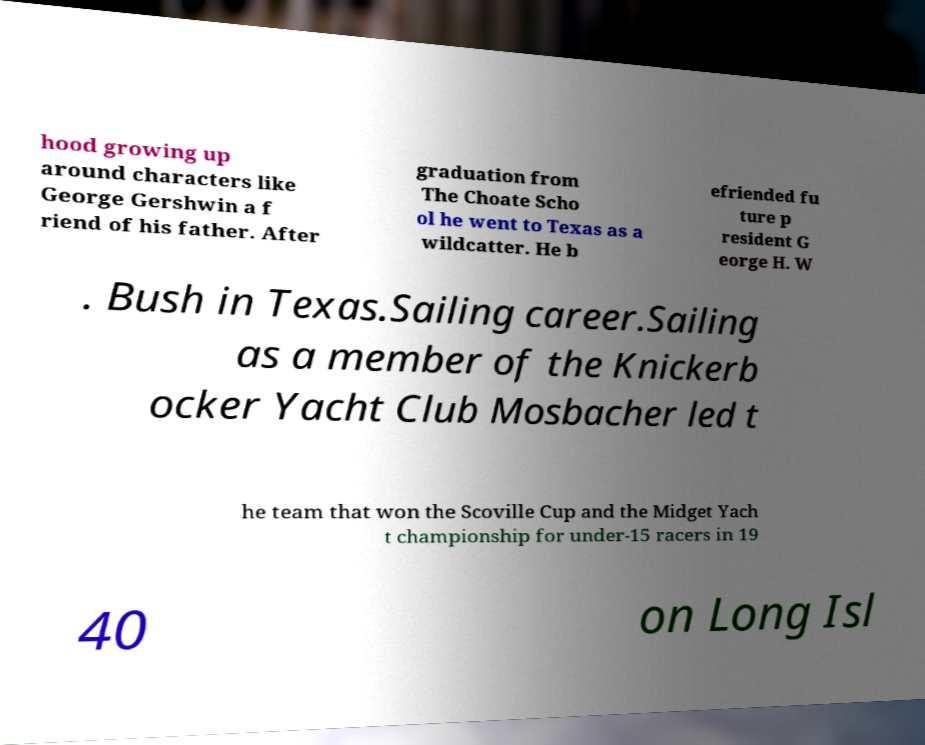Could you extract and type out the text from this image? hood growing up around characters like George Gershwin a f riend of his father. After graduation from The Choate Scho ol he went to Texas as a wildcatter. He b efriended fu ture p resident G eorge H. W . Bush in Texas.Sailing career.Sailing as a member of the Knickerb ocker Yacht Club Mosbacher led t he team that won the Scoville Cup and the Midget Yach t championship for under-15 racers in 19 40 on Long Isl 